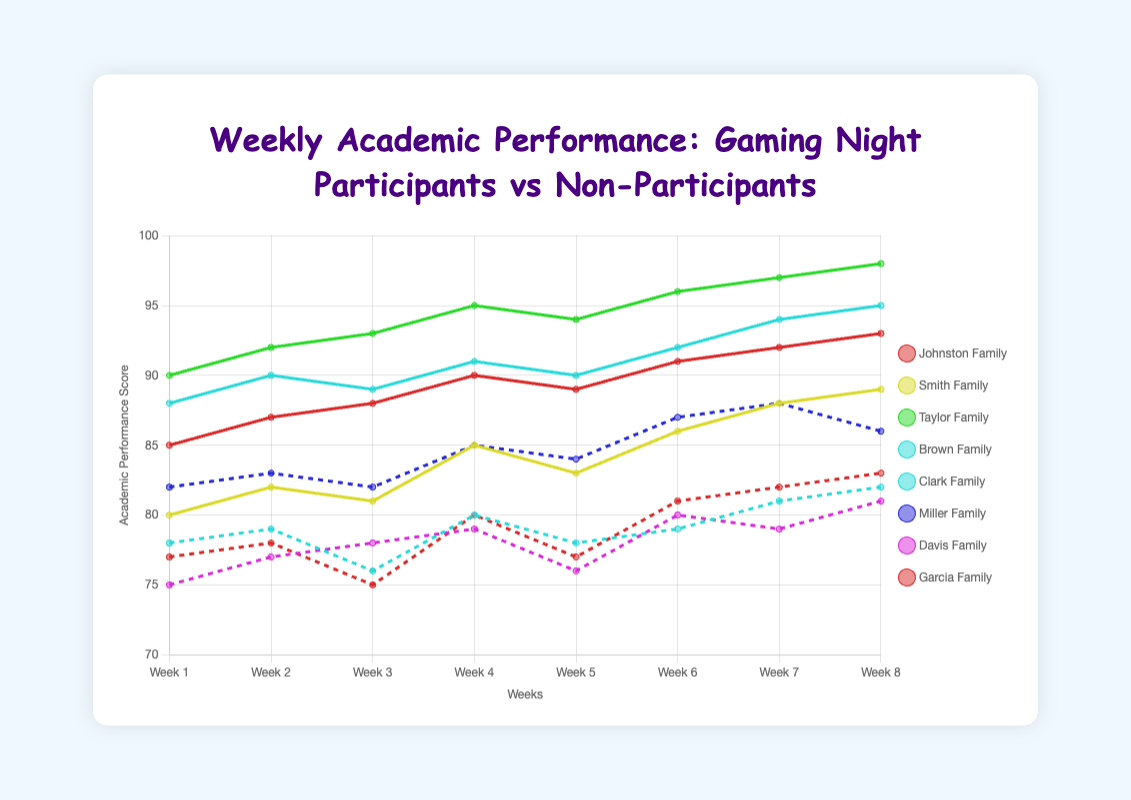Which family of non-participants had the highest academic performance in week 4? Looking at week 4 for non-participants, compare the academic scores of each family. Clark Family: 80, Miller Family: 85, Davis Family: 79, Garcia Family: 80. The Miller Family has the highest score.
Answer: Miller Family What is the average academic performance score of the Johnston Family over the 8 weeks? Sum up Johnston Family's scores over 8 weeks (85 + 87 + 88 + 90 + 89 + 91 + 92 + 93) = 715. Divide by 8 weeks to get the average: 715 / 8 = 89.375.
Answer: 89.375 How does the academic performance of participants compare to non-participants in week 7? Compare the average scores of participants and non-participants in week 7. Participants: (92+88+97+94)/4 = 92.75. Non-Participants: (81+88+79+82)/4 = 82.5. The participants have a higher average score.
Answer: Participants have higher scores What is the trend of academic performance for the Taylor Family over the 8 weeks? Look at the scores of the Taylor Family each week: 90, 92, 93, 95, 94, 96, 97, 98. The scores steadily increase over time.
Answer: Increasing trend Which family shows the most consistent academic performance over the 8 weeks among non-participants? Calculate the variance in scores for each non-participant family. Clark Family: [78, 79, 76, 80, 78, 79, 81, 82], Miller Family: [82, 83, 82, 85, 84, 87, 88, 86], Davis Family: [75, 77, 78, 79, 76, 80, 79, 81], Garcia Family: [77, 78, 75, 80, 77, 81, 82, 83]. The Miller Family has the smallest range (82-88 = 6).
Answer: Miller Family What is the difference in the academic performance of the Smith Family between weeks 4 and 5? Subtract the Smith Family's score in week 4 from their score in week 5: 85 - 83 = 2.
Answer: 2 In week 8, which group (participants or non-participants) has the higher minimum academic score, and what is it? Participants' scores in week 8: 93, 89, 98, 95. Non-participants' scores: 82, 86, 81, 83. The minimum score for participants is 89, and for non-participants is 81. So, participants have a higher minimum score.
Answer: Participants, 89 